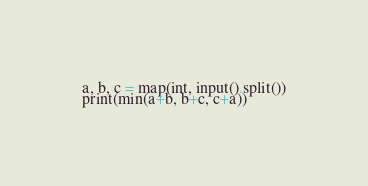<code> <loc_0><loc_0><loc_500><loc_500><_Python_>a, b, c = map(int, input().split())
print(min(a+b, b+c, c+a))</code> 